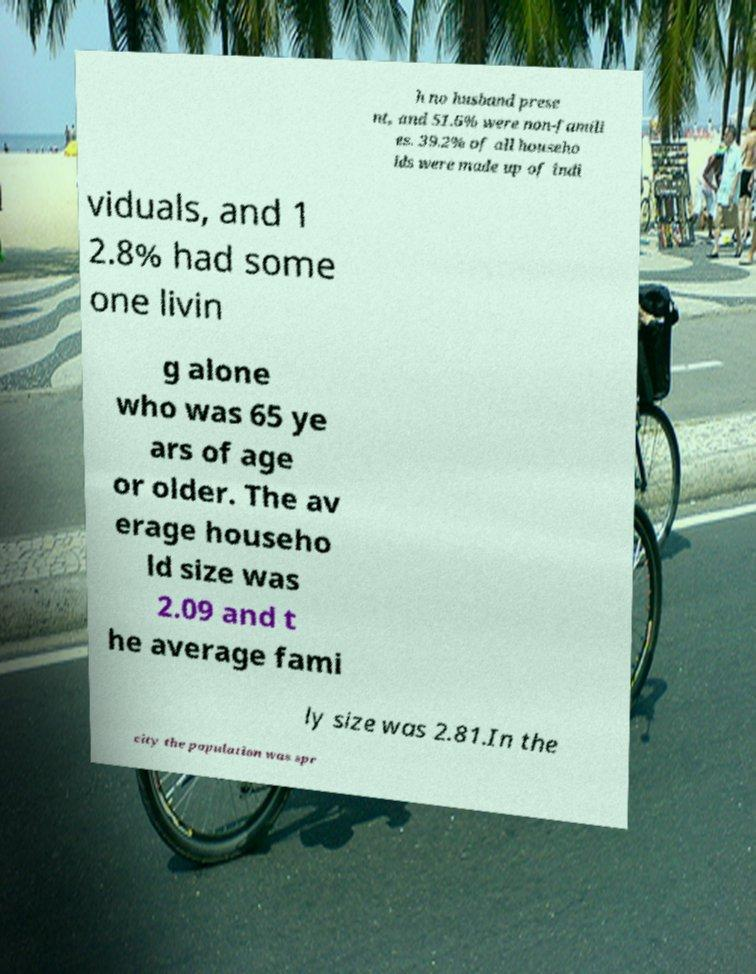What messages or text are displayed in this image? I need them in a readable, typed format. h no husband prese nt, and 51.6% were non-famili es. 39.2% of all househo lds were made up of indi viduals, and 1 2.8% had some one livin g alone who was 65 ye ars of age or older. The av erage househo ld size was 2.09 and t he average fami ly size was 2.81.In the city the population was spr 